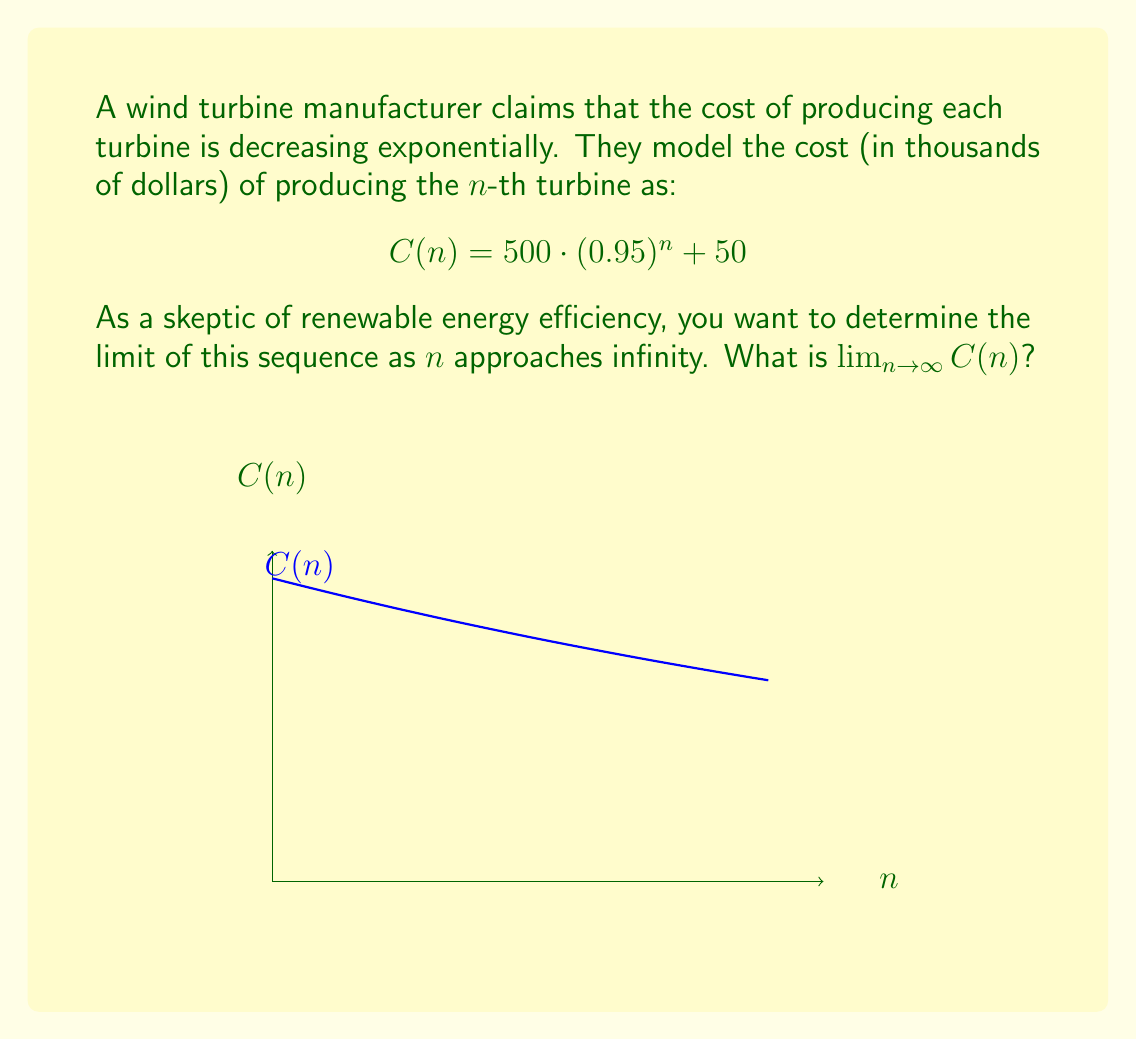Could you help me with this problem? To find the limit of this sequence, we'll follow these steps:

1) First, let's examine the general form of the sequence:
   $$C(n) = 500 \cdot (0.95)^n + 50$$

2) As $n$ approaches infinity, we need to consider two parts:
   a) $500 \cdot (0.95)^n$
   b) $50$

3) For part (a):
   $\lim_{n \to \infty} 500 \cdot (0.95)^n$
   Since $0 < 0.95 < 1$, as $n$ approaches infinity, $(0.95)^n$ approaches 0.
   Therefore, $\lim_{n \to \infty} 500 \cdot (0.95)^n = 500 \cdot 0 = 0$

4) For part (b):
   $\lim_{n \to \infty} 50 = 50$ (constant term)

5) Combining the limits:
   $\lim_{n \to \infty} C(n) = \lim_{n \to \infty} (500 \cdot (0.95)^n + 50)$
   $= \lim_{n \to \infty} 500 \cdot (0.95)^n + \lim_{n \to \infty} 50$
   $= 0 + 50 = 50$

Therefore, the limit of the sequence as $n$ approaches infinity is 50.
Answer: $50$ 